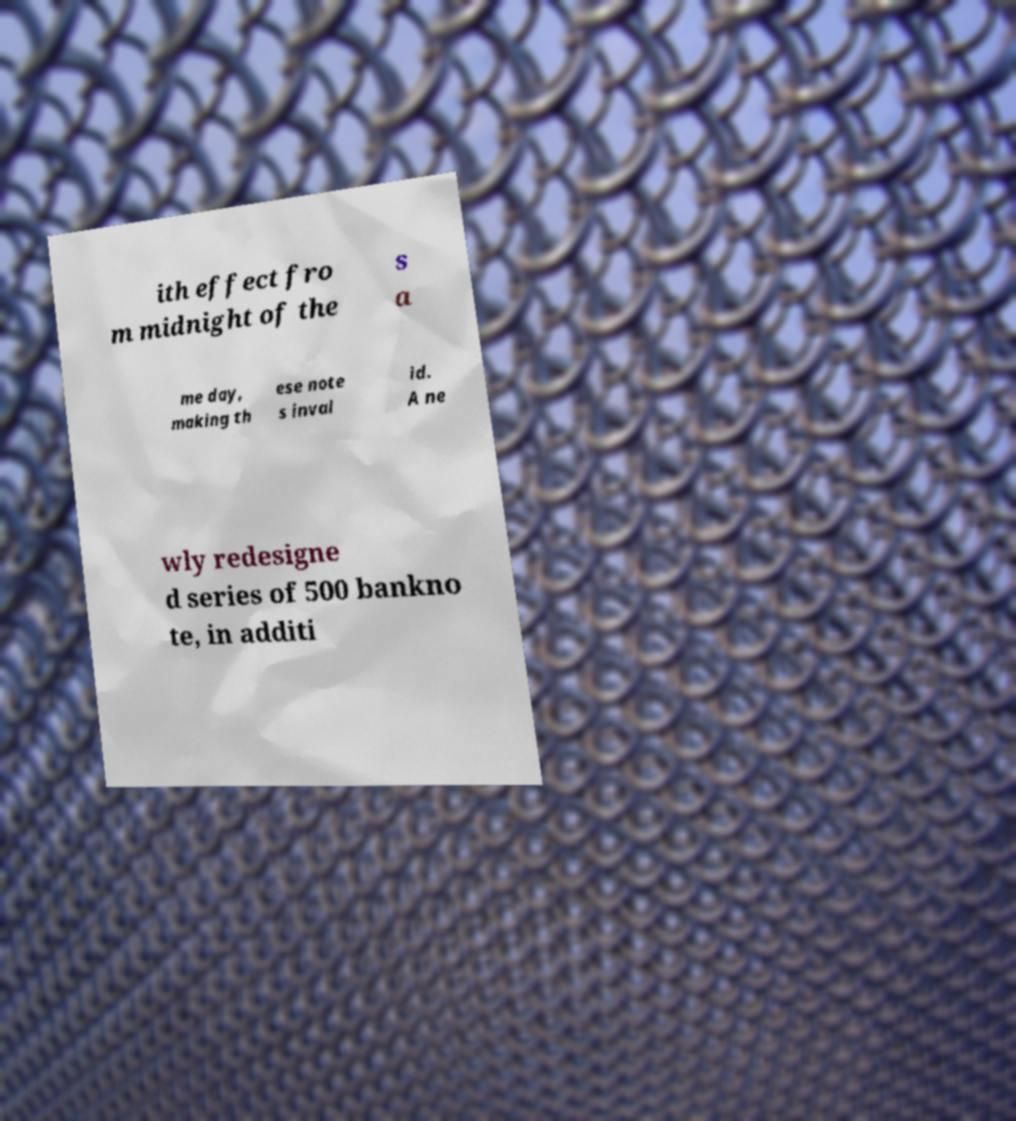Can you read and provide the text displayed in the image?This photo seems to have some interesting text. Can you extract and type it out for me? ith effect fro m midnight of the s a me day, making th ese note s inval id. A ne wly redesigne d series of 500 bankno te, in additi 